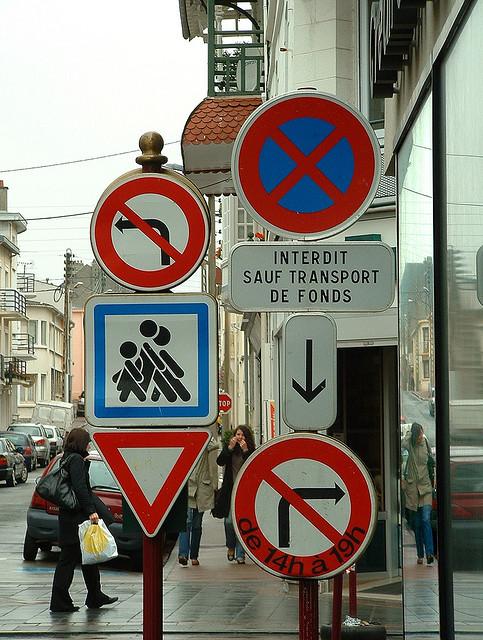What do the written signs say?
Answer briefly. Interdit sauf transport de fonds. Which way can you go?
Be succinct. Straight. How many signs are shown?
Concise answer only. 7. What colors are the sign on top?
Keep it brief. Red and blue. What is on the woman's shopping bag?
Answer briefly. Yellow. 